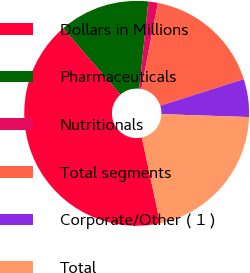Convert chart to OTSL. <chart><loc_0><loc_0><loc_500><loc_500><pie_chart><fcel>Dollars in Millions<fcel>Pharmaceuticals<fcel>Nutritionals<fcel>Total segments<fcel>Corporate/Other ( 1 )<fcel>Total<nl><fcel>42.01%<fcel>12.99%<fcel>1.38%<fcel>17.06%<fcel>5.44%<fcel>21.12%<nl></chart> 